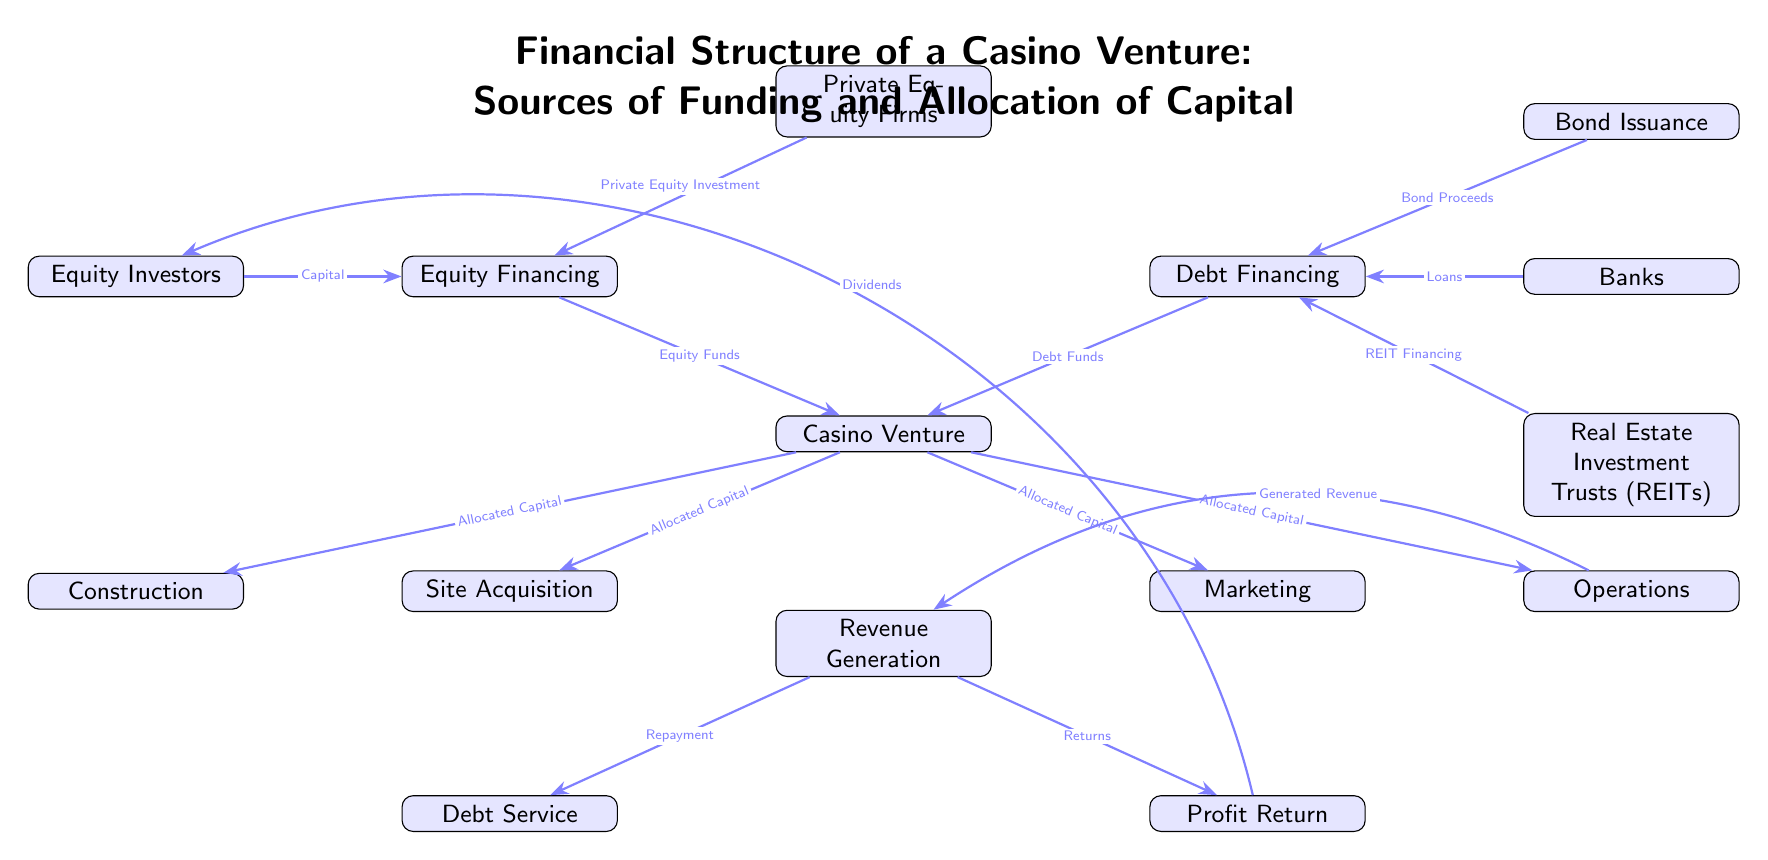What are the two main sources of funding for the casino venture? The diagram identifies two primary sources of funding: Equity Financing and Debt Financing, which are positioned directly above the Casino Venture node.
Answer: Equity Financing, Debt Financing How many types of equity financing are listed in the diagram? The diagram clearly shows two types of equity financing: Equity Investors and Private Equity Firms, which are both branches under the Equity Financing node.
Answer: 2 What do banks provide to the casino venture? According to the diagram, banks provide loans, as indicated by the edge from Banks to Debt.
Answer: Loans What is the flow of funds from Deck to Casino Venture? The flow starts from Banks, Bonds, and Real Estate Investment Trusts, which all provide their respective funds (Loans, Bond Proceeds, REIT Financing) to the Debt node, which then directs Debt Funds to the Casino Venture.
Answer: Debt Funds What allocation is given to site acquisition from the casino venture? The Casino Venture allocates capital to Site Acquisition, as indicated by the edge labeled "Allocated Capital" flowing from the Casino Venture node to the Site Acquisition node.
Answer: Allocated Capital What percentage of generated revenue is allocated to debt service? The diagram does not specify a percentage, but it indicates a flow from Revenue directly to Debt Service for repayment. Therefore, the flow may suggest that a certain amount of unspecific revenue goes towards debt service.
Answer: Not specified Which category involves marketing expenses in the funding structure? The funding structure allocates capital to the Marketing node, which is placed to the right of the Casino Venture in the diagram.
Answer: Marketing How is profit returned to equity investors? The profit return to equity investors is done through dividends, indicated by the edge from Profit Return to Equity Investors labeled "Dividends."
Answer: Dividends 